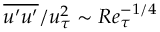Convert formula to latex. <formula><loc_0><loc_0><loc_500><loc_500>\overline { { u ^ { \prime } u ^ { \prime } } } / u _ { \tau } ^ { 2 } \sim R e _ { \tau } ^ { - 1 / 4 }</formula> 